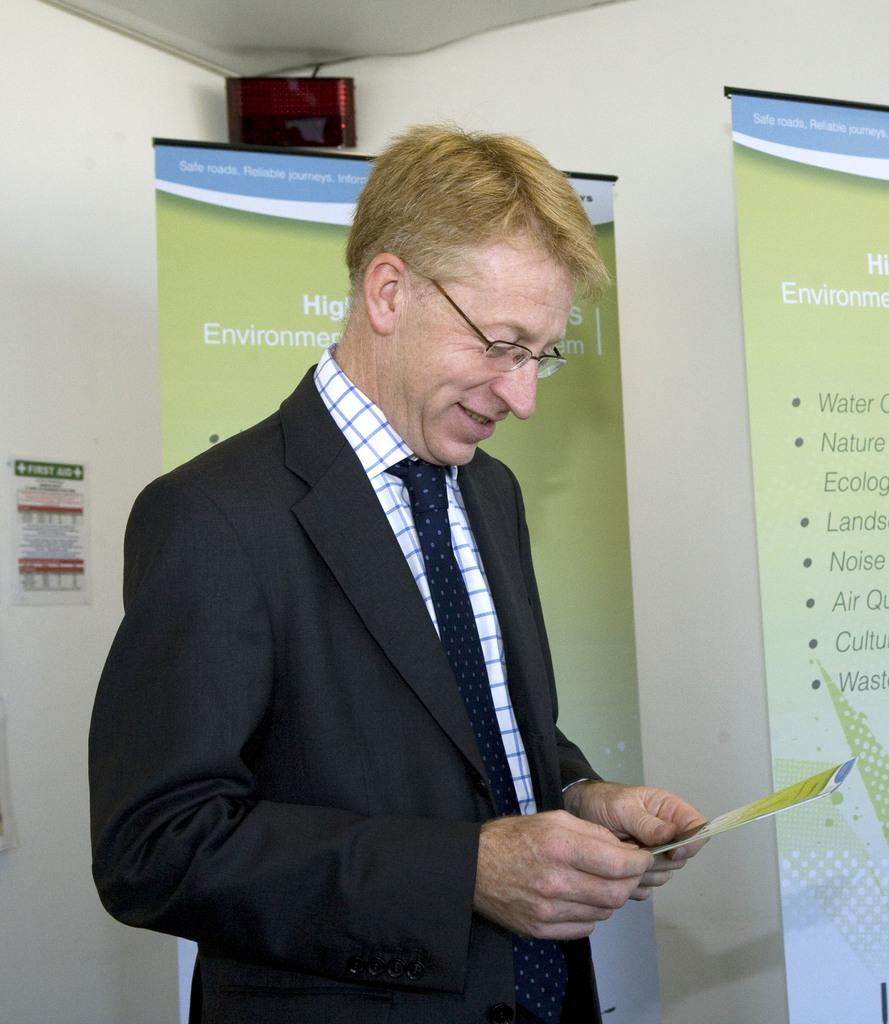What is the main subject of the image? The main subject of the image is a person. What type of clothing is the person wearing? The person is wearing a blazer, a shirt, and a tie. What accessory is the person wearing? The person is wearing spectacles. What is the person's facial expression? The person is smiling. What can be seen in the background of the image? There are banners, an LED display, and a wall in the background of the image. Can you tell me how many buttons are on the playground in the image? There is no playground present in the image, and therefore no buttons can be found on it. What type of passenger is sitting next to the person in the image? There is no indication of any passengers in the image, as it only features a single person. 